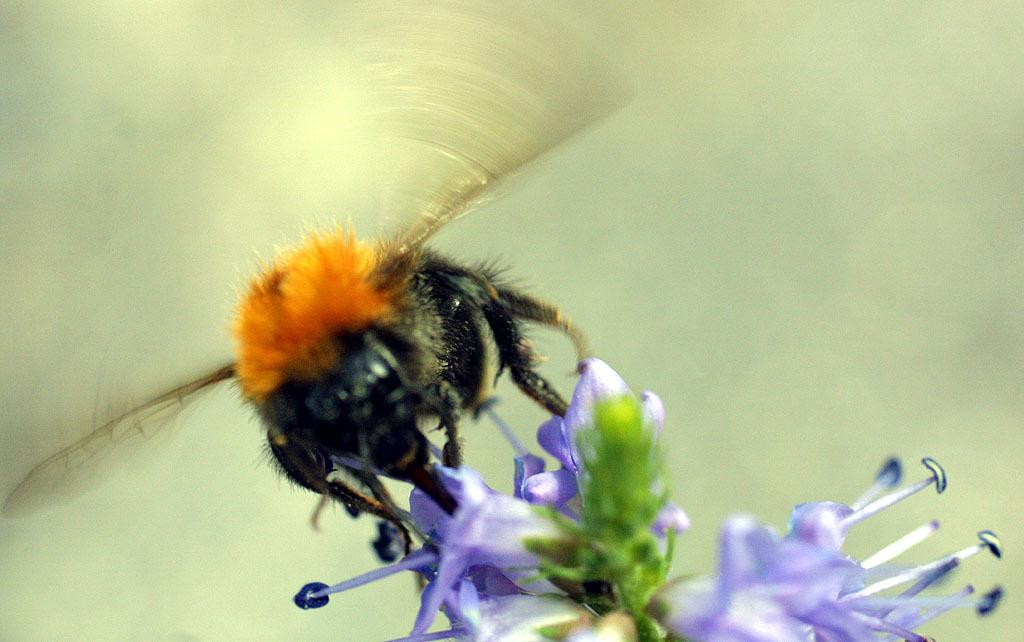What is the main subject of the picture? The main subject of the picture is a bee. Where is the bee located in the image? The bee is sitting on a flower in the picture. What else can be seen in the image besides the bee? There are buds in the picture. Can you describe the background of the image? The backdrop of the image is blurred. How many cherries are being crushed by the bee in the image? There are no cherries present in the image, and the bee is not shown crushing anything. 